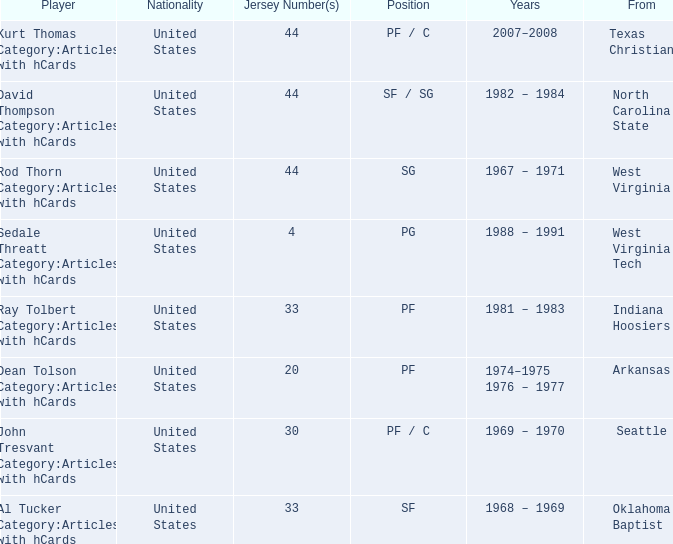Who was the player that was from west virginia tech? Sedale Threatt Category:Articles with hCards. 